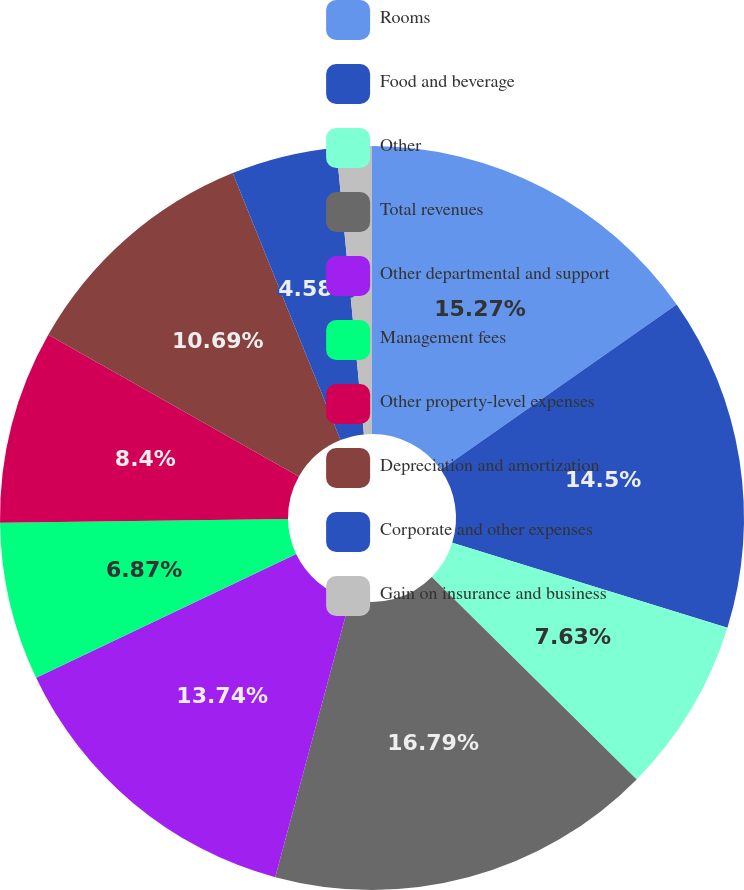<chart> <loc_0><loc_0><loc_500><loc_500><pie_chart><fcel>Rooms<fcel>Food and beverage<fcel>Other<fcel>Total revenues<fcel>Other departmental and support<fcel>Management fees<fcel>Other property-level expenses<fcel>Depreciation and amortization<fcel>Corporate and other expenses<fcel>Gain on insurance and business<nl><fcel>15.27%<fcel>14.5%<fcel>7.63%<fcel>16.79%<fcel>13.74%<fcel>6.87%<fcel>8.4%<fcel>10.69%<fcel>4.58%<fcel>1.53%<nl></chart> 